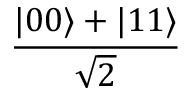<formula> <loc_0><loc_0><loc_500><loc_500>\frac { | 0 0 \rangle + | 1 1 \rangle } { \sqrt { 2 } }</formula> 